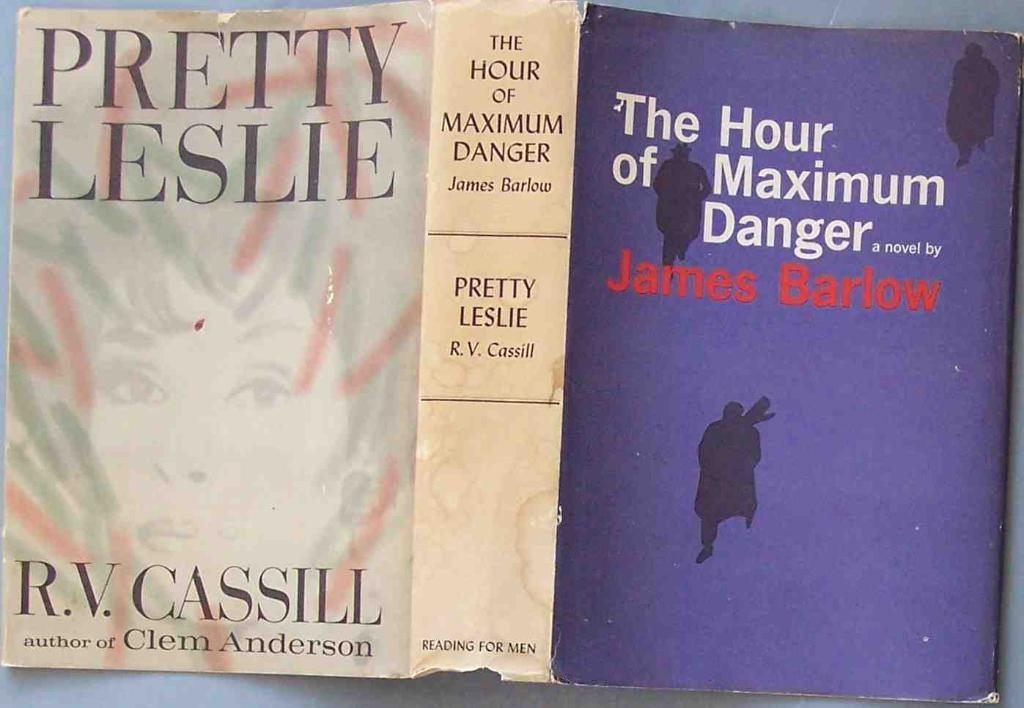<image>
Render a clear and concise summary of the photo. the paper book cover of the book called The hour of maximum danger is on a table 